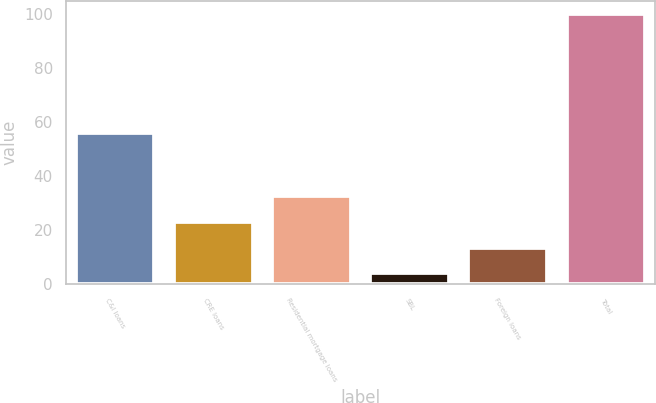Convert chart. <chart><loc_0><loc_0><loc_500><loc_500><bar_chart><fcel>C&I loans<fcel>CRE loans<fcel>Residential mortgage loans<fcel>SBL<fcel>Foreign loans<fcel>Total<nl><fcel>56<fcel>23.2<fcel>32.8<fcel>4<fcel>13.6<fcel>100<nl></chart> 